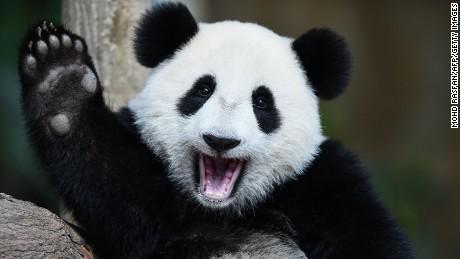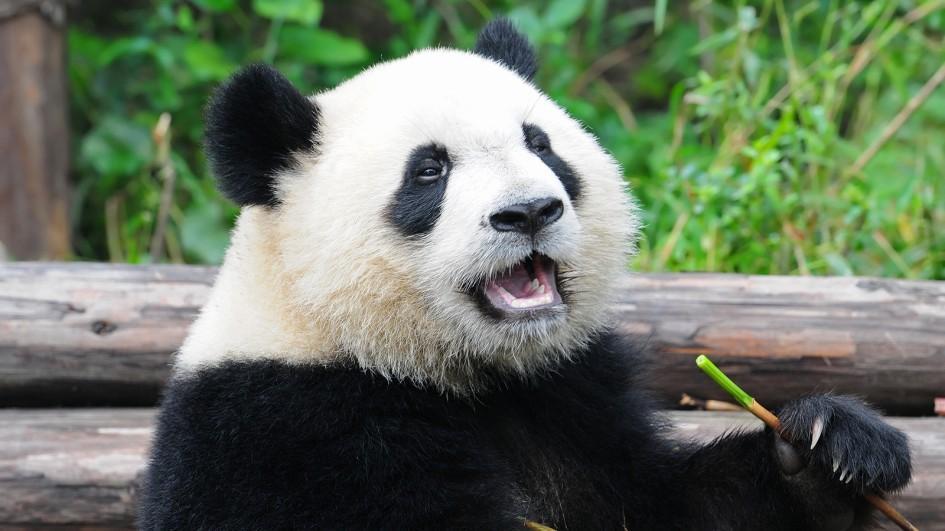The first image is the image on the left, the second image is the image on the right. Given the left and right images, does the statement "An image shows an adult panda on its back, playing with a young panda on top." hold true? Answer yes or no. No. 